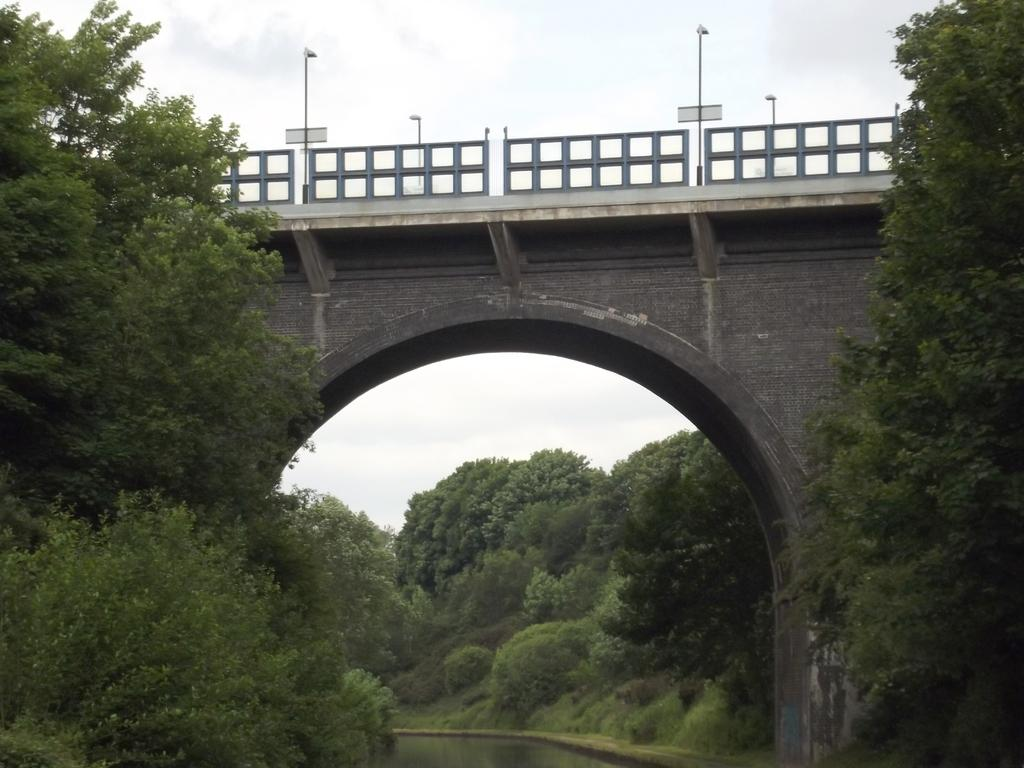What structure is the main subject of the image? There is a bridge in the image. What features can be seen on the bridge? The bridge has railings and light poles. Is there any architectural detail on the bridge? Yes, there is an arch on the bridge. What type of vegetation is present near the bridge? Trees are present on the sides of the bridge. What can be seen at the bottom of the bridge? There is water at the bottom of the bridge. What is visible in the background of the image? The sky is visible in the background of the image. How many plants are growing on the legs of the bridge in the image? There are no plants growing on the legs of the bridge, as the bridge does not have legs. What historical event is depicted in the image? There is no historical event depicted in the image; it is a picture of a bridge with its features and surroundings. 